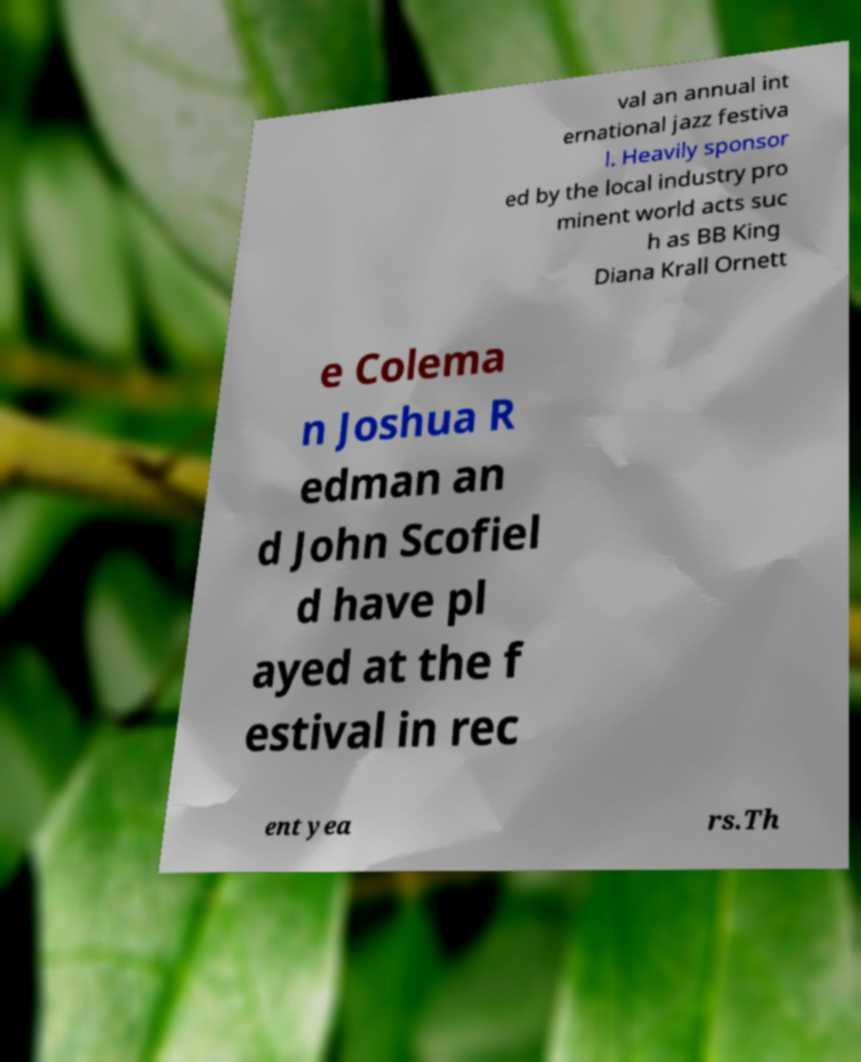Could you assist in decoding the text presented in this image and type it out clearly? val an annual int ernational jazz festiva l. Heavily sponsor ed by the local industry pro minent world acts suc h as BB King Diana Krall Ornett e Colema n Joshua R edman an d John Scofiel d have pl ayed at the f estival in rec ent yea rs.Th 